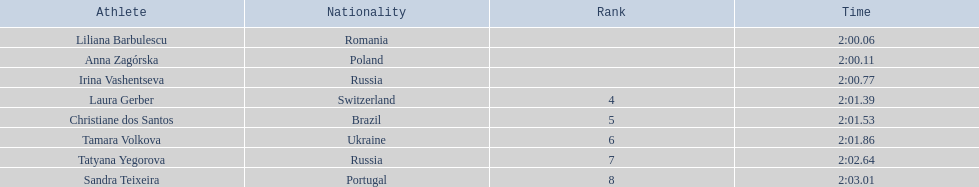Who are all of the athletes? Liliana Barbulescu, Anna Zagórska, Irina Vashentseva, Laura Gerber, Christiane dos Santos, Tamara Volkova, Tatyana Yegorova, Sandra Teixeira. What were their times in the heat? 2:00.06, 2:00.11, 2:00.77, 2:01.39, 2:01.53, 2:01.86, 2:02.64, 2:03.01. Of these, which is the top time? 2:00.06. Which athlete had this time? Liliana Barbulescu. Can you give me this table in json format? {'header': ['Athlete', 'Nationality', 'Rank', 'Time'], 'rows': [['Liliana Barbulescu', 'Romania', '', '2:00.06'], ['Anna Zagórska', 'Poland', '', '2:00.11'], ['Irina Vashentseva', 'Russia', '', '2:00.77'], ['Laura Gerber', 'Switzerland', '4', '2:01.39'], ['Christiane dos Santos', 'Brazil', '5', '2:01.53'], ['Tamara Volkova', 'Ukraine', '6', '2:01.86'], ['Tatyana Yegorova', 'Russia', '7', '2:02.64'], ['Sandra Teixeira', 'Portugal', '8', '2:03.01']]} 